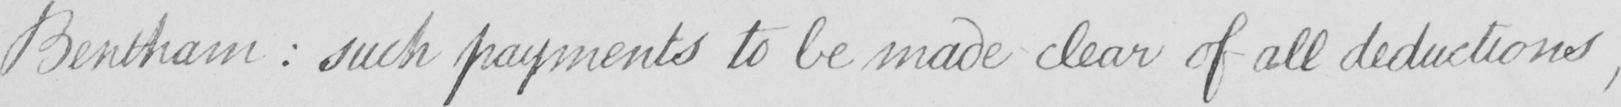Transcribe the text shown in this historical manuscript line. Bentham  :  such payments to be made clear of all deductions , 